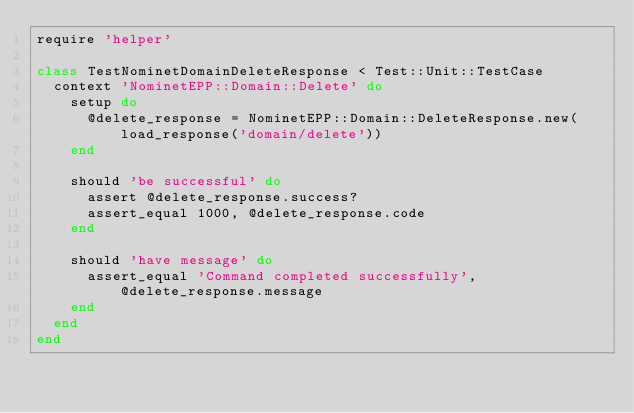<code> <loc_0><loc_0><loc_500><loc_500><_Ruby_>require 'helper'

class TestNominetDomainDeleteResponse < Test::Unit::TestCase
  context 'NominetEPP::Domain::Delete' do
    setup do
      @delete_response = NominetEPP::Domain::DeleteResponse.new(load_response('domain/delete'))
    end

    should 'be successful' do
      assert @delete_response.success?
      assert_equal 1000, @delete_response.code
    end

    should 'have message' do
      assert_equal 'Command completed successfully', @delete_response.message
    end
  end
end
</code> 